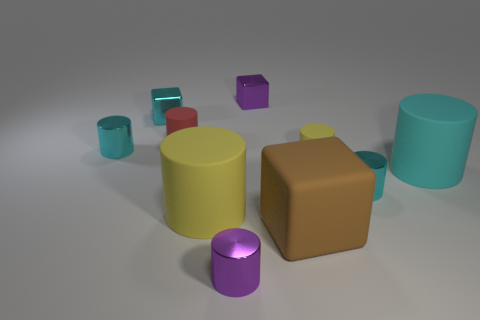What color is the block that is made of the same material as the small red cylinder?
Offer a terse response. Brown. What number of shiny blocks have the same size as the cyan matte cylinder?
Your answer should be very brief. 0. How many other objects are there of the same color as the rubber block?
Give a very brief answer. 0. There is a big yellow rubber thing that is on the right side of the cyan cube; does it have the same shape as the large matte object on the right side of the small yellow cylinder?
Provide a succinct answer. Yes. There is a brown rubber thing that is the same size as the cyan rubber thing; what shape is it?
Your answer should be compact. Cube. Is the number of big cyan rubber cylinders that are to the left of the big brown matte object the same as the number of small red rubber things behind the tiny cyan shiny cube?
Your answer should be compact. Yes. Are the tiny purple object behind the small red thing and the small red cylinder made of the same material?
Make the answer very short. No. What material is the cyan cube that is the same size as the red matte thing?
Provide a succinct answer. Metal. What number of other things are there of the same material as the small purple block
Ensure brevity in your answer.  4. There is a cyan matte object; does it have the same size as the block in front of the red object?
Provide a succinct answer. Yes. 